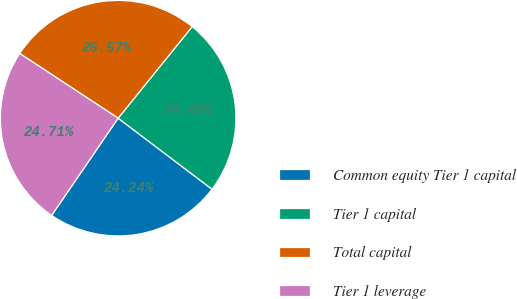<chart> <loc_0><loc_0><loc_500><loc_500><pie_chart><fcel>Common equity Tier 1 capital<fcel>Tier 1 capital<fcel>Total capital<fcel>Tier 1 leverage<nl><fcel>24.24%<fcel>24.48%<fcel>26.57%<fcel>24.71%<nl></chart> 